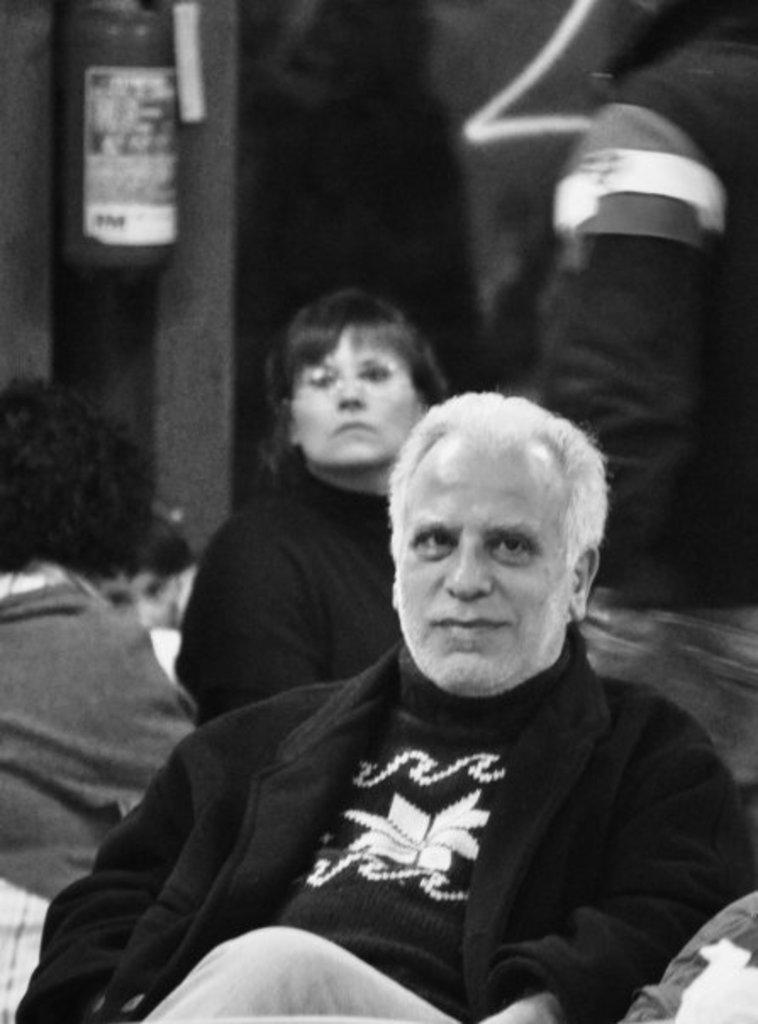What is the color scheme of the image? The image is black and white. What are the people in the image doing? The people in the image are sitting. What safety device can be seen in the background of the image? There is a fire extinguisher in the background of the image. How would you describe the background of the image? The background appears blurred. Can you tell me how many seeds are on the table in the image? There are no seeds present in the image; it features people sitting in a black and white setting with a blurred background and a fire extinguisher. 